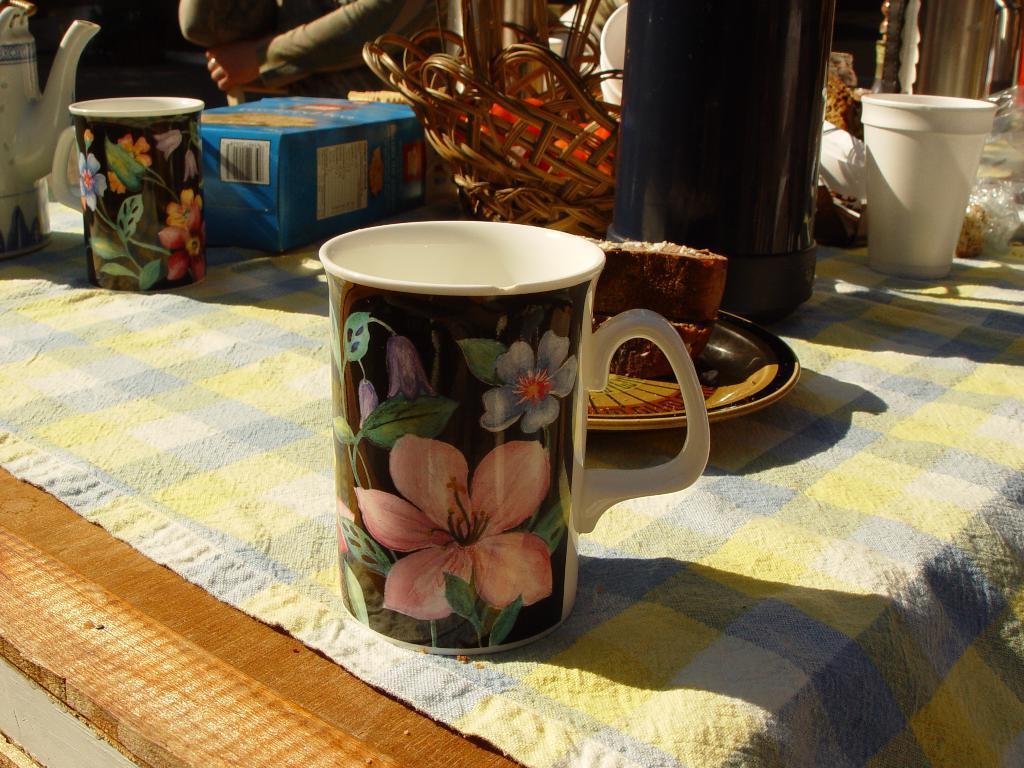Could you give a brief overview of what you see in this image? There are some cups,a bottle and a kettle on a table. 